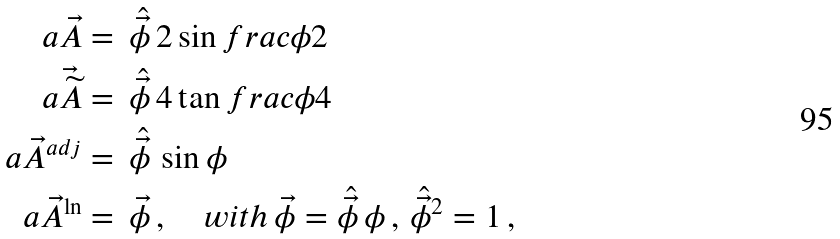<formula> <loc_0><loc_0><loc_500><loc_500>a \vec { A } & = \, \hat { \vec { \phi } } \, { 2 } \sin f r a c { \phi } { 2 } \\ a \vec { \widetilde { A } } & = \, \hat { \vec { \phi } } \, { 4 } \tan f r a c { \phi } { 4 } \\ a \vec { A } ^ { a d j } & = \, \hat { \vec { \phi } } \, \sin \phi \\ a \vec { A } ^ { \ln } & = \, \vec { \phi } \, , \quad w i t h \, \vec { \phi } = \hat { \vec { \phi } } \, \phi \, , \, \hat { \vec { \phi } } ^ { 2 } = 1 \, ,</formula> 